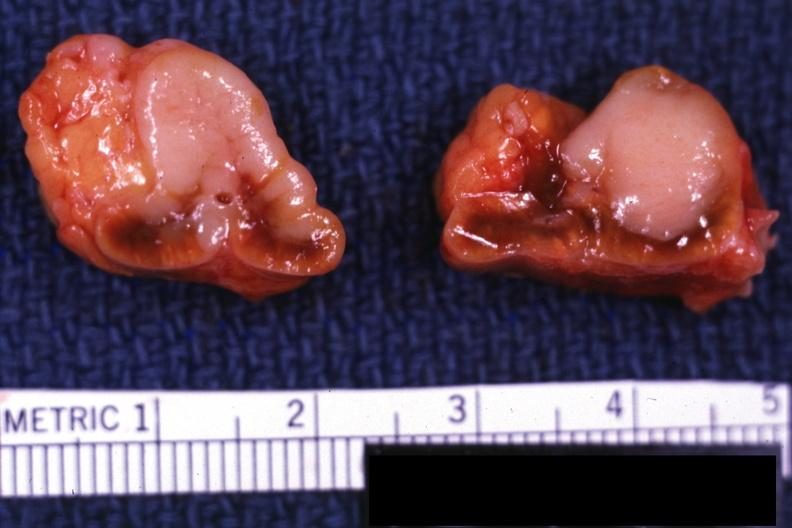what is present?
Answer the question using a single word or phrase. Adrenal 